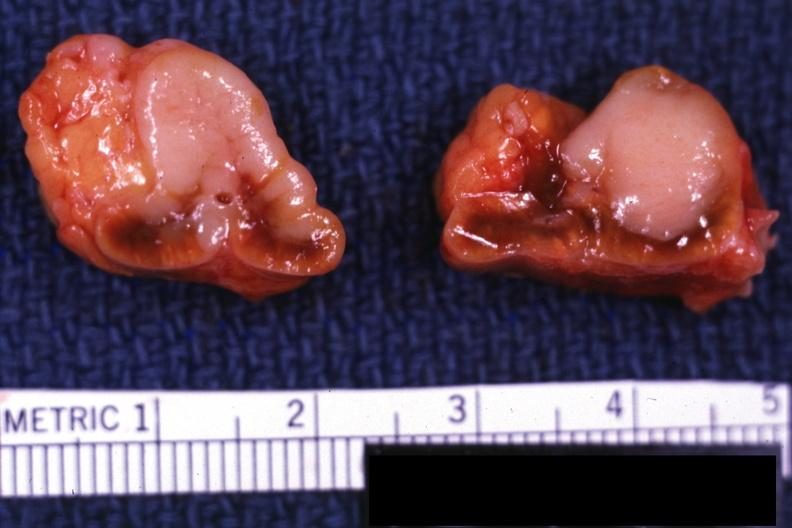what is present?
Answer the question using a single word or phrase. Adrenal 